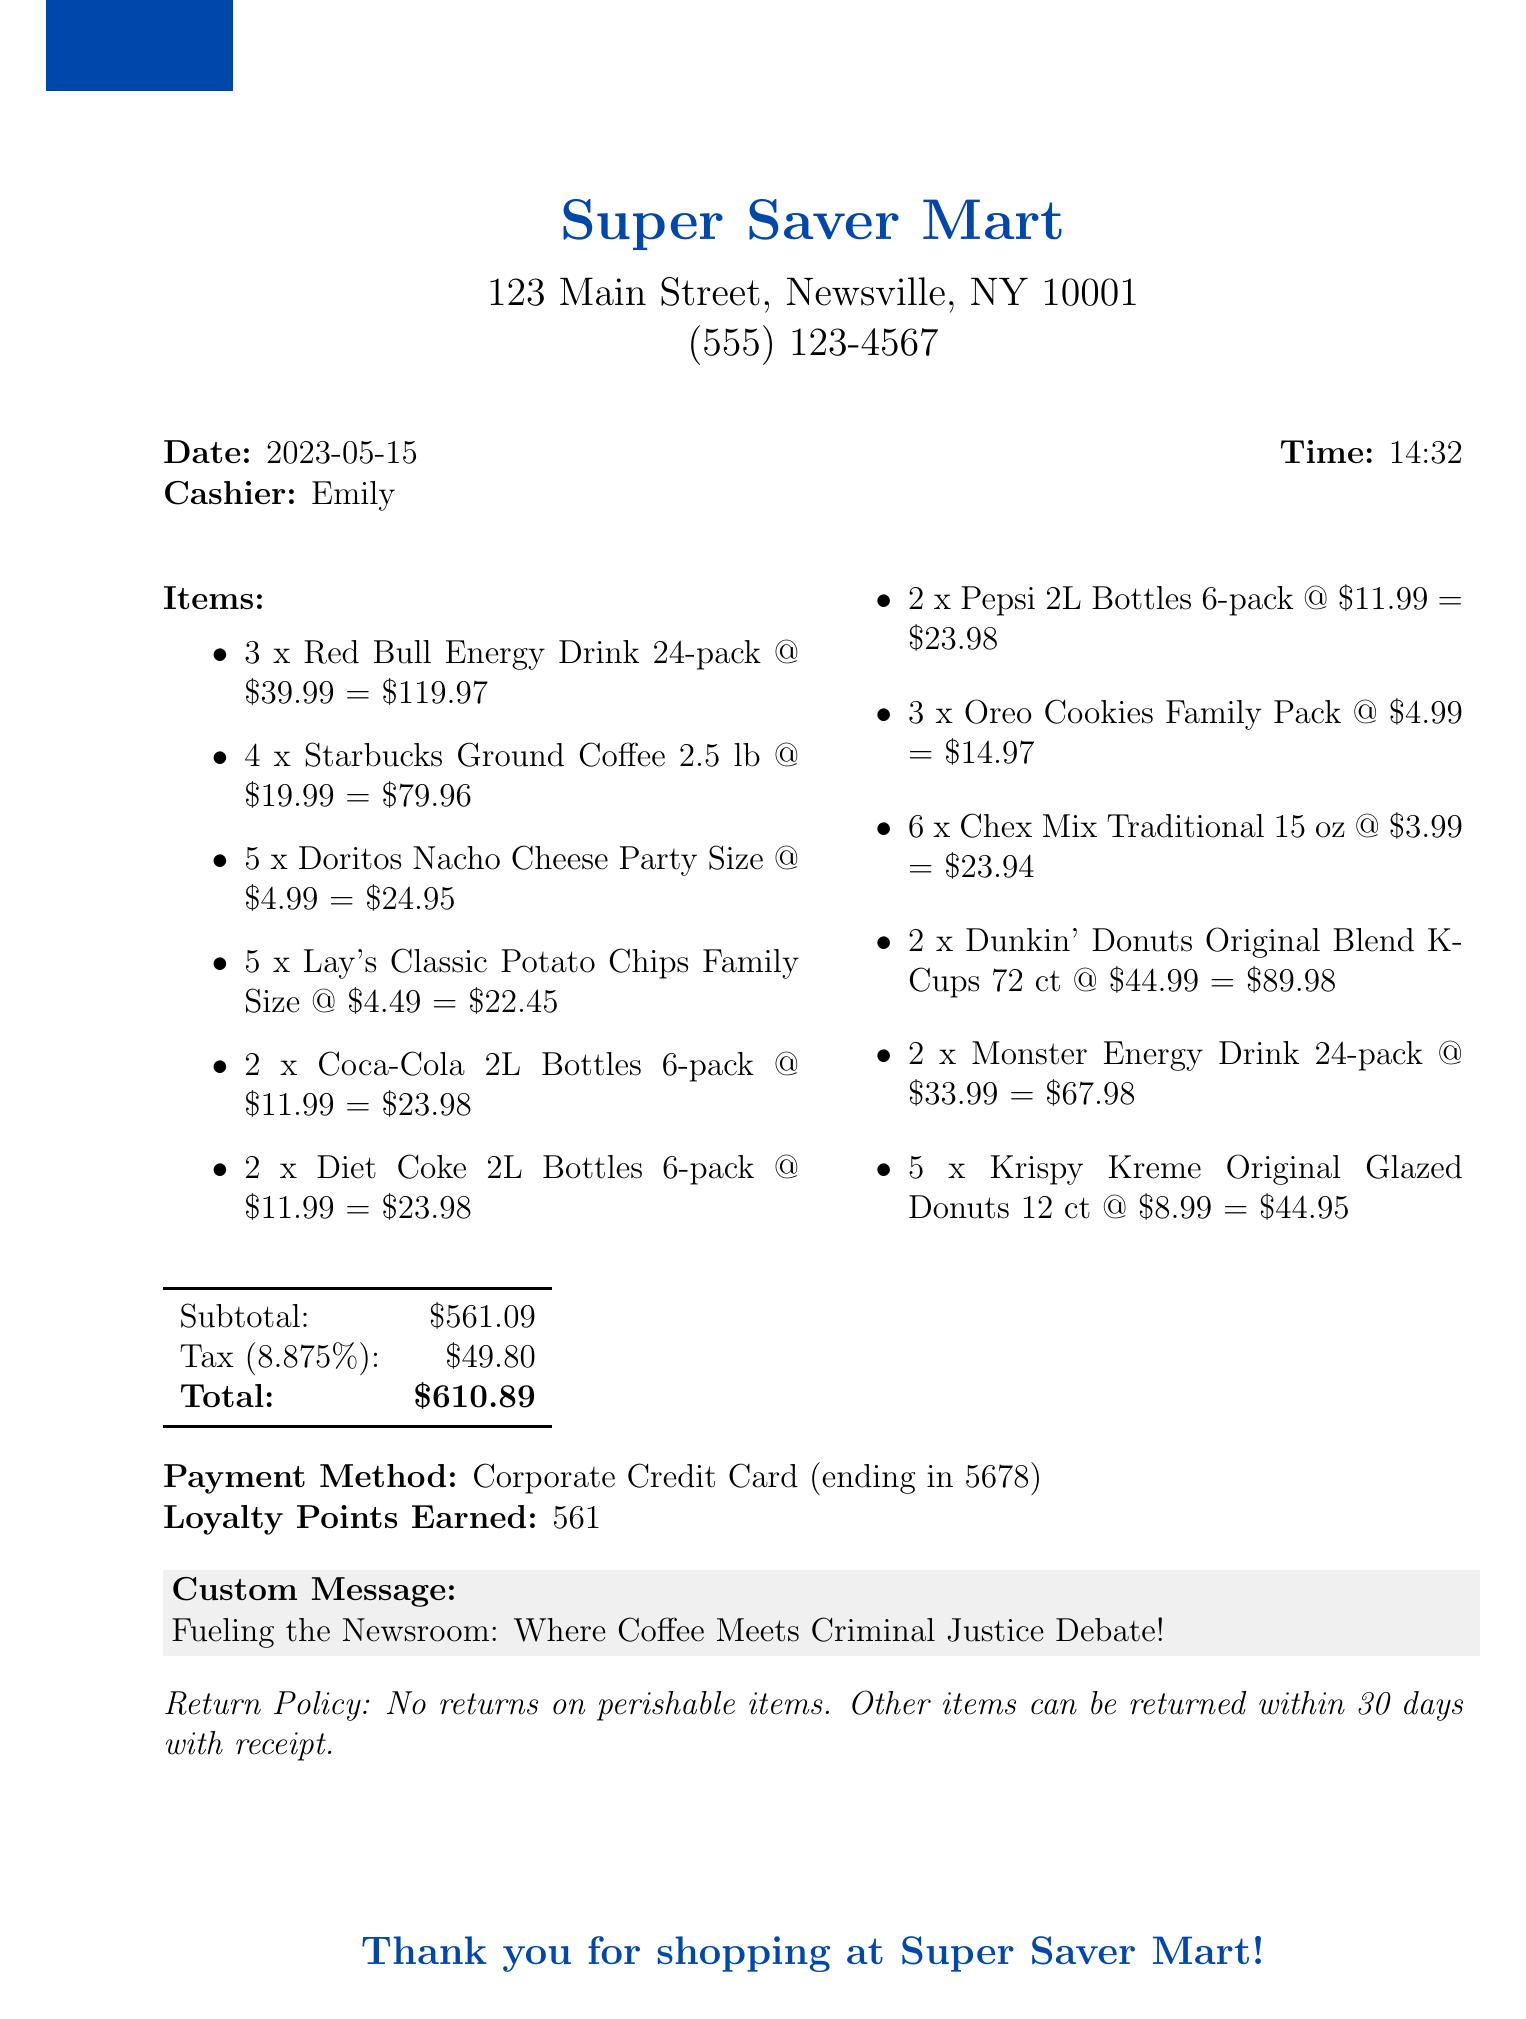What is the store name? The store name is clearly indicated at the top of the receipt.
Answer: Super Saver Mart What is the total amount? The total amount is found near the end of the receipt, summarizing the purchase.
Answer: $610.89 Who was the cashier? The cashier's name is listed right after the date and time.
Answer: Emily How many packs of Red Bull Energy Drinks were purchased? The quantity of a specific item can be found in the itemized list on the receipt.
Answer: 3 What is the tax rate? The tax rate is stated in the summary section of the receipt.
Answer: 8.875% What is the subtotal before tax? The subtotal is given before the tax amount in the summary of the purchase.
Answer: $561.09 How many loyalty points were earned? The earned loyalty points are mentioned in the payment summary section.
Answer: 561 What is the return policy for perishable items? The return policy specifies conditions related to different items, particularly perishable ones.
Answer: No returns on perishable items What payment method was used? The payment method is outlined in the summary details at the end of the receipt.
Answer: Corporate Credit Card 